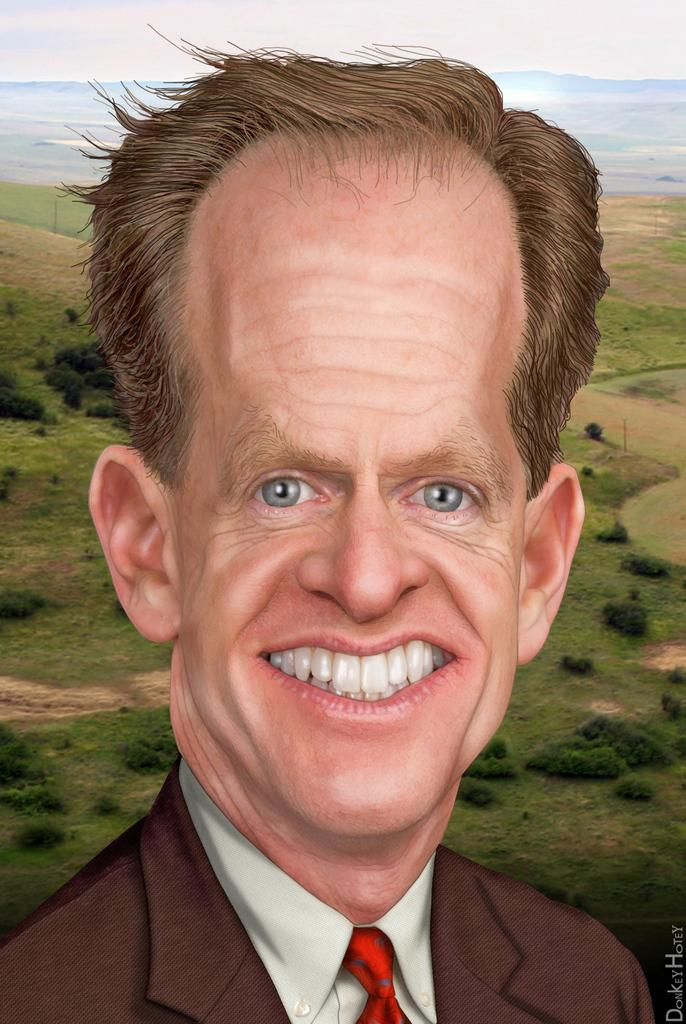What type of artwork is shown in the image? The image is a painting. What is the main subject of the painting? There is a person's face depicted in the painting. What can be seen in the background of the painting? There are trees, grass, and water in the background of the painting. What type of fowl is depicted wearing a mask in the painting? There is no fowl or mask present in the painting; it depicts a person's face with a background of trees, grass, and water. Who is the person's partner in the painting? There is no indication of a partner in the painting; it only depicts a person's face with a background of trees, grass, and water. 